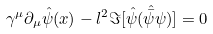Convert formula to latex. <formula><loc_0><loc_0><loc_500><loc_500>\gamma ^ { \mu } \partial _ { \mu } { \hat { \psi } ( x ) } - l ^ { 2 } \Im [ { \hat { \psi } } ( { \hat { \bar { \psi } } } \psi ) ] = 0</formula> 